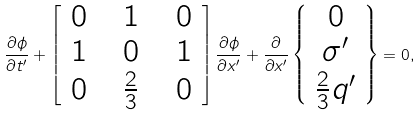<formula> <loc_0><loc_0><loc_500><loc_500>\frac { \partial \phi } { \partial t ^ { \prime } } + \begin{bmatrix} \ 0 \ & \ 1 \ & \ 0 \ \\ 1 & 0 & 1 \\ 0 & \frac { 2 } { 3 } & 0 \end{bmatrix} \frac { \partial \phi } { \partial x ^ { \prime } } + \frac { \partial } { \partial x ^ { \prime } } \left \{ \begin{array} { c } 0 \\ \sigma ^ { \prime } \\ \frac { 2 } { 3 } q ^ { \prime } \end{array} \right \} = 0 ,</formula> 